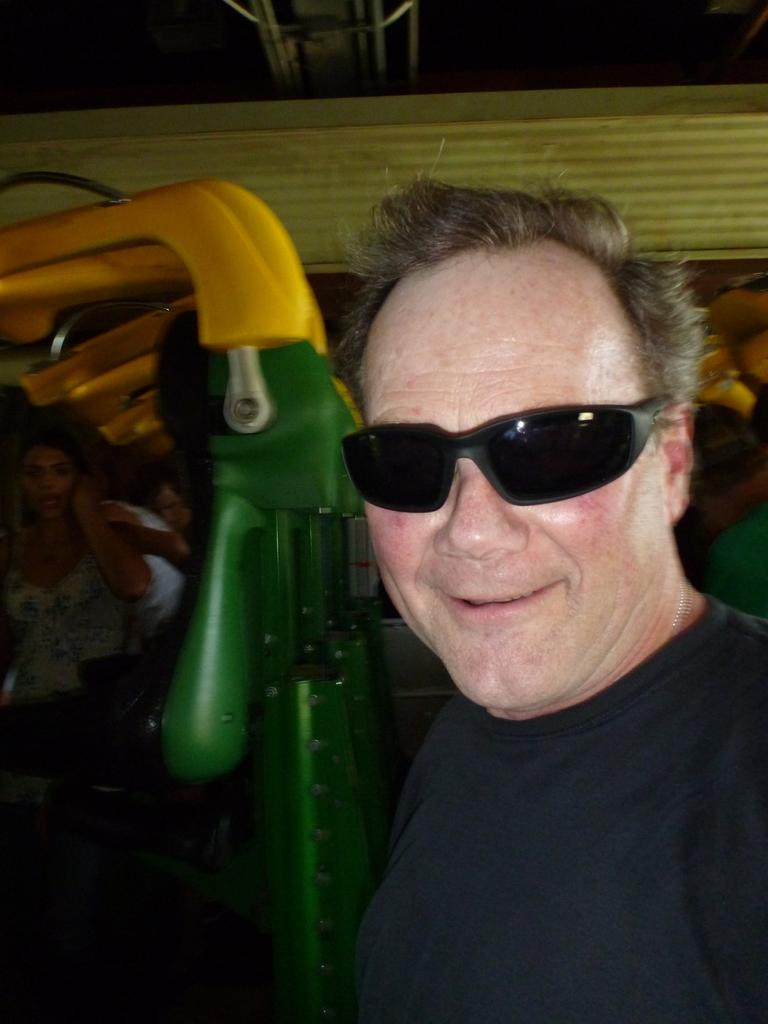What is the person in the foreground of the image wearing? The person in the image is wearing spectacles. What can be seen in the background of the image? There are people and rods visible in the background of the image. What type of rice can be seen growing in the image? There is no rice present in the image. What is the person in the image knitting with wool? There is no wool or knitting activity depicted in the image. 